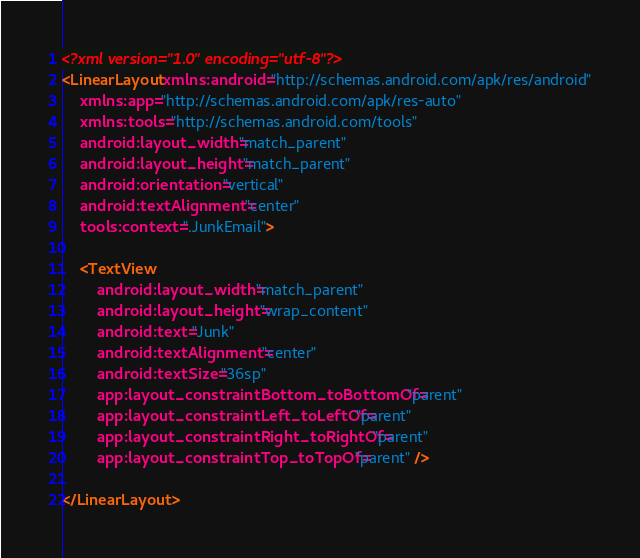<code> <loc_0><loc_0><loc_500><loc_500><_XML_><?xml version="1.0" encoding="utf-8"?>
<LinearLayout xmlns:android="http://schemas.android.com/apk/res/android"
    xmlns:app="http://schemas.android.com/apk/res-auto"
    xmlns:tools="http://schemas.android.com/tools"
    android:layout_width="match_parent"
    android:layout_height="match_parent"
    android:orientation="vertical"
    android:textAlignment="center"
    tools:context=".JunkEmail">

    <TextView
        android:layout_width="match_parent"
        android:layout_height="wrap_content"
        android:text="Junk"
        android:textAlignment="center"
        android:textSize="36sp"
        app:layout_constraintBottom_toBottomOf="parent"
        app:layout_constraintLeft_toLeftOf="parent"
        app:layout_constraintRight_toRightOf="parent"
        app:layout_constraintTop_toTopOf="parent" />

</LinearLayout></code> 